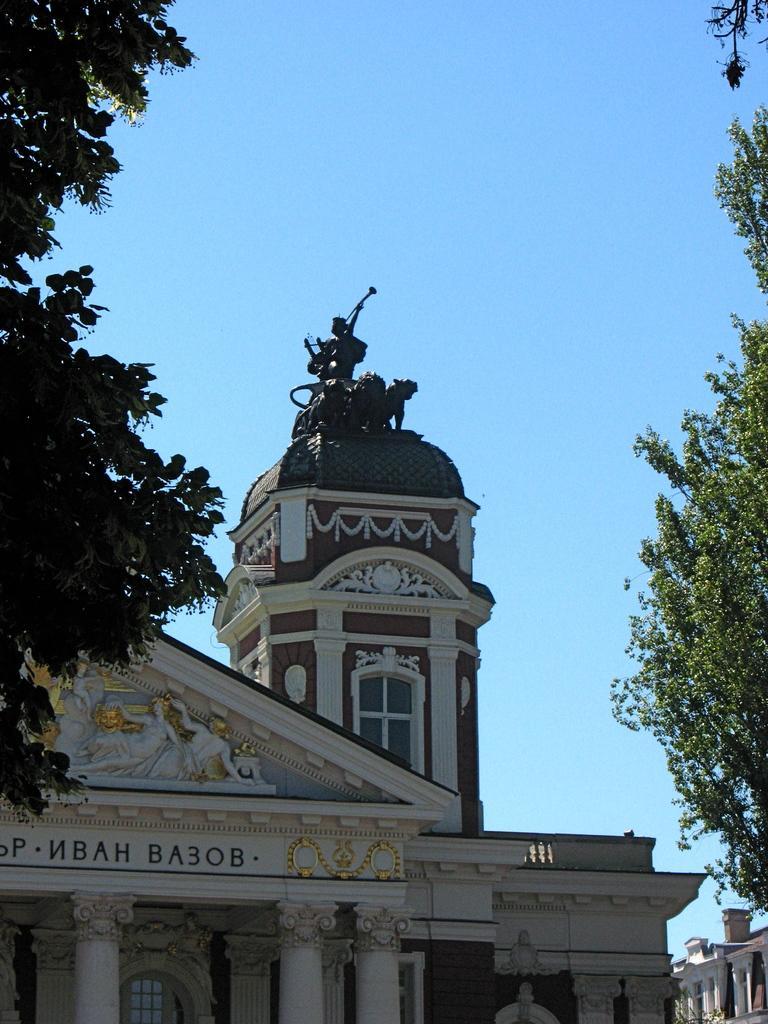Describe this image in one or two sentences. In this picture we can see a building, windows, sculptures, trees and pillars. There is something written on the wall of a building. On the top of a building we can see a statue. In the background we can see the sky. 